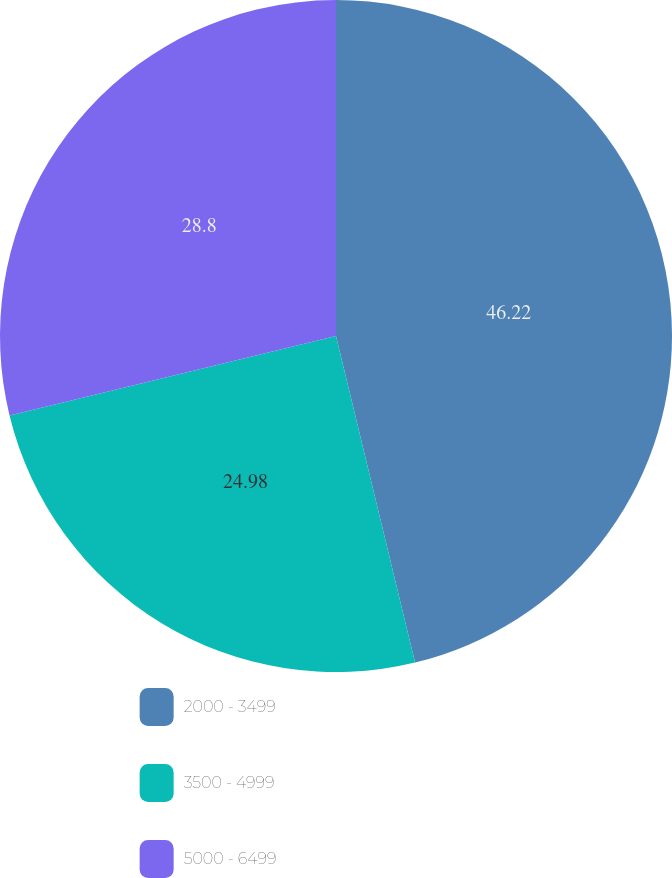Convert chart. <chart><loc_0><loc_0><loc_500><loc_500><pie_chart><fcel>2000 - 3499<fcel>3500 - 4999<fcel>5000 - 6499<nl><fcel>46.22%<fcel>24.98%<fcel>28.8%<nl></chart> 